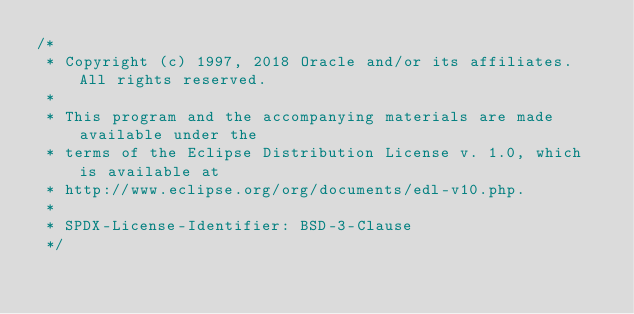<code> <loc_0><loc_0><loc_500><loc_500><_Java_>/*
 * Copyright (c) 1997, 2018 Oracle and/or its affiliates. All rights reserved.
 *
 * This program and the accompanying materials are made available under the
 * terms of the Eclipse Distribution License v. 1.0, which is available at
 * http://www.eclipse.org/org/documents/edl-v10.php.
 *
 * SPDX-License-Identifier: BSD-3-Clause
 */
</code> 